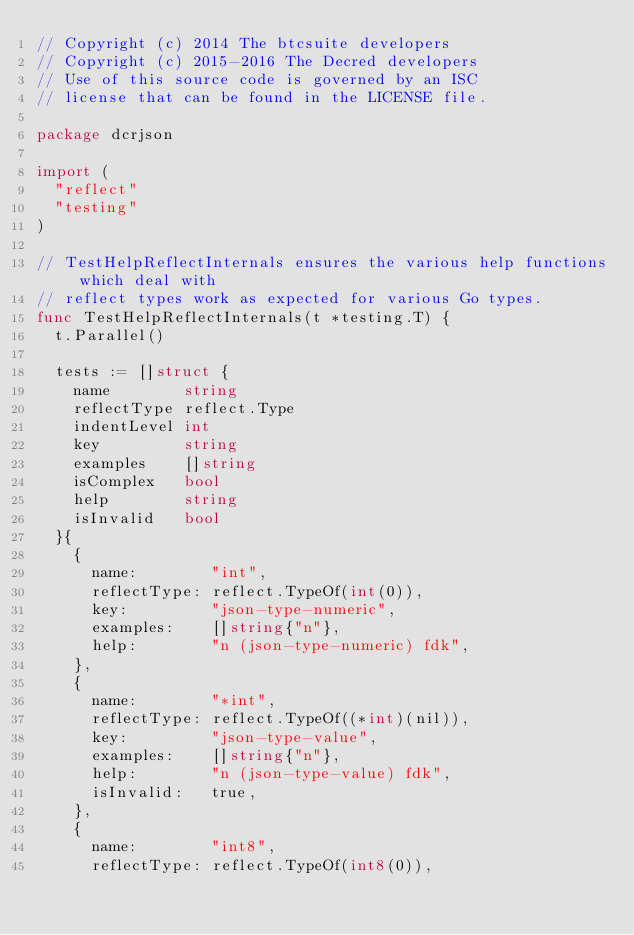Convert code to text. <code><loc_0><loc_0><loc_500><loc_500><_Go_>// Copyright (c) 2014 The btcsuite developers
// Copyright (c) 2015-2016 The Decred developers
// Use of this source code is governed by an ISC
// license that can be found in the LICENSE file.

package dcrjson

import (
	"reflect"
	"testing"
)

// TestHelpReflectInternals ensures the various help functions which deal with
// reflect types work as expected for various Go types.
func TestHelpReflectInternals(t *testing.T) {
	t.Parallel()

	tests := []struct {
		name        string
		reflectType reflect.Type
		indentLevel int
		key         string
		examples    []string
		isComplex   bool
		help        string
		isInvalid   bool
	}{
		{
			name:        "int",
			reflectType: reflect.TypeOf(int(0)),
			key:         "json-type-numeric",
			examples:    []string{"n"},
			help:        "n (json-type-numeric) fdk",
		},
		{
			name:        "*int",
			reflectType: reflect.TypeOf((*int)(nil)),
			key:         "json-type-value",
			examples:    []string{"n"},
			help:        "n (json-type-value) fdk",
			isInvalid:   true,
		},
		{
			name:        "int8",
			reflectType: reflect.TypeOf(int8(0)),</code> 